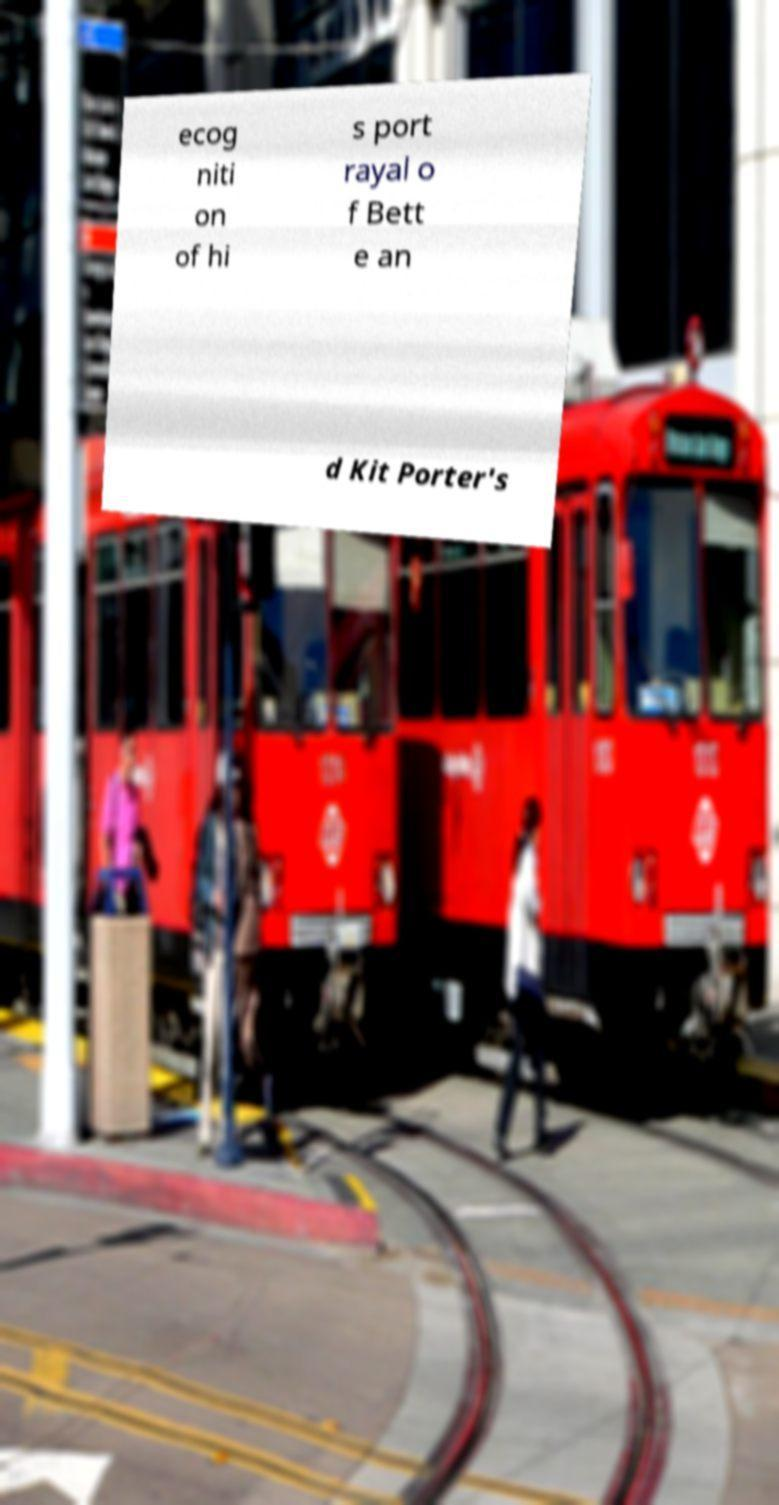Could you assist in decoding the text presented in this image and type it out clearly? ecog niti on of hi s port rayal o f Bett e an d Kit Porter's 